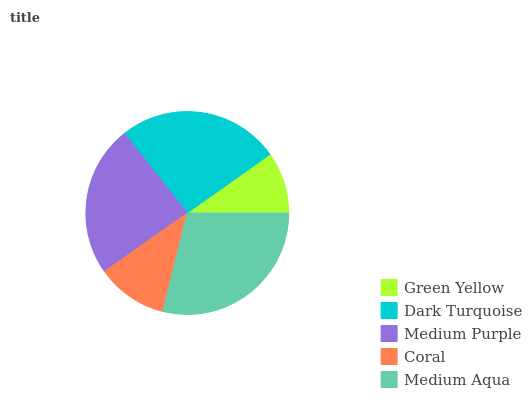Is Green Yellow the minimum?
Answer yes or no. Yes. Is Medium Aqua the maximum?
Answer yes or no. Yes. Is Dark Turquoise the minimum?
Answer yes or no. No. Is Dark Turquoise the maximum?
Answer yes or no. No. Is Dark Turquoise greater than Green Yellow?
Answer yes or no. Yes. Is Green Yellow less than Dark Turquoise?
Answer yes or no. Yes. Is Green Yellow greater than Dark Turquoise?
Answer yes or no. No. Is Dark Turquoise less than Green Yellow?
Answer yes or no. No. Is Medium Purple the high median?
Answer yes or no. Yes. Is Medium Purple the low median?
Answer yes or no. Yes. Is Green Yellow the high median?
Answer yes or no. No. Is Coral the low median?
Answer yes or no. No. 